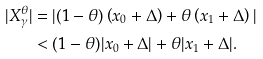Convert formula to latex. <formula><loc_0><loc_0><loc_500><loc_500>| X _ { \gamma } ^ { \theta } | & = | ( 1 - \theta ) \left ( x _ { 0 } + \Delta \right ) + \theta \left ( x _ { 1 } + \Delta \right ) | \\ & < ( 1 - \theta ) | x _ { 0 } + \Delta | + \theta | x _ { 1 } + \Delta | .</formula> 